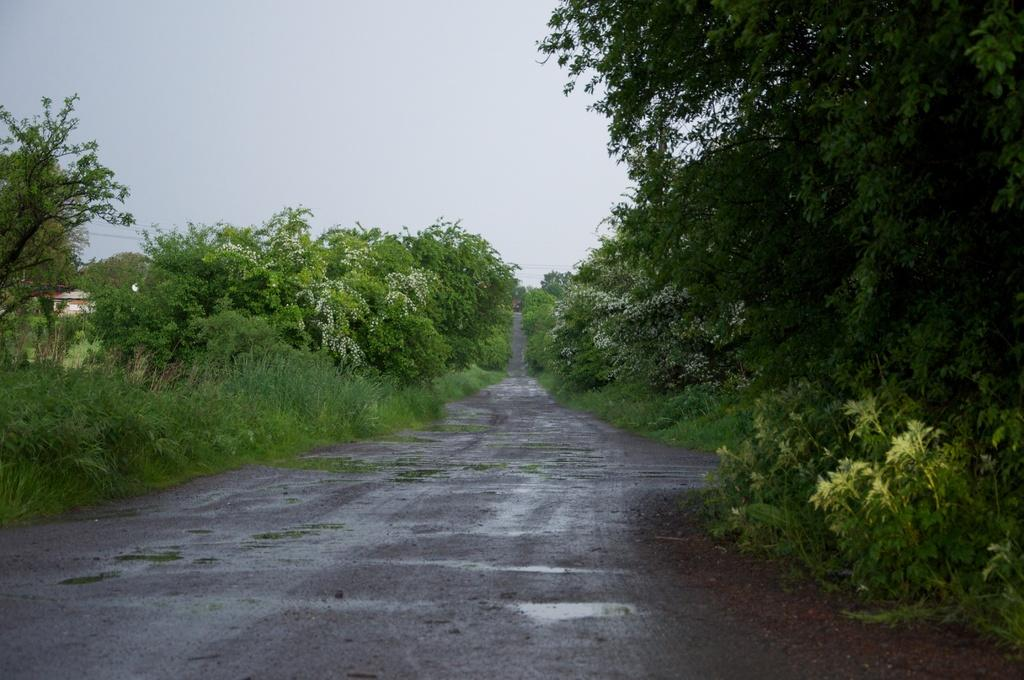What type of pathway is visible in the image? There is a road in the image. What other natural elements can be seen in the image? There are plants and trees in the image. What type of structure is present in the image? There is a house in the image. What can be seen in the background of the image? The sky is visible in the background of the image. Where is the cushion placed in the image? There is no cushion present in the image. What type of achievement is being celebrated in the image? There is no indication of a celebration or achievement in the image. 